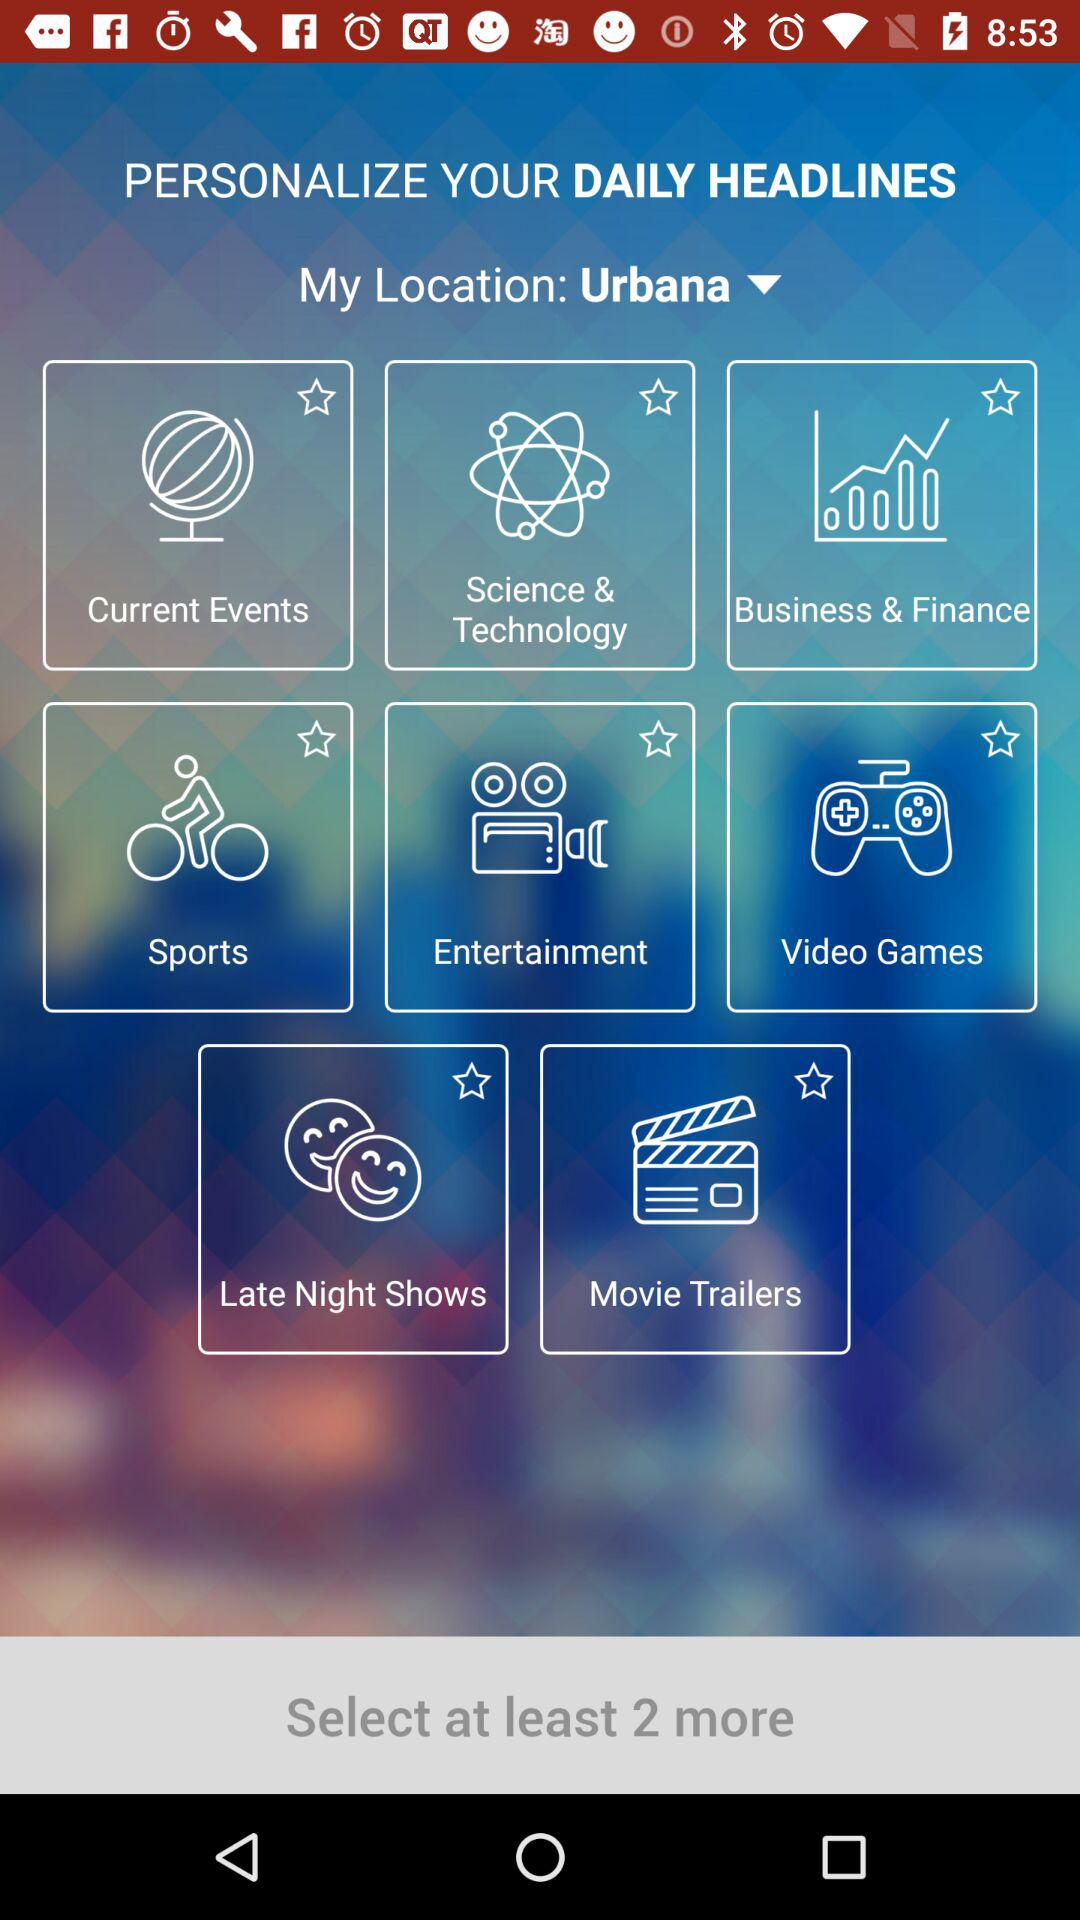What is "My Location" shown on the screen? "My Location" shown on the screen is Urbana. 